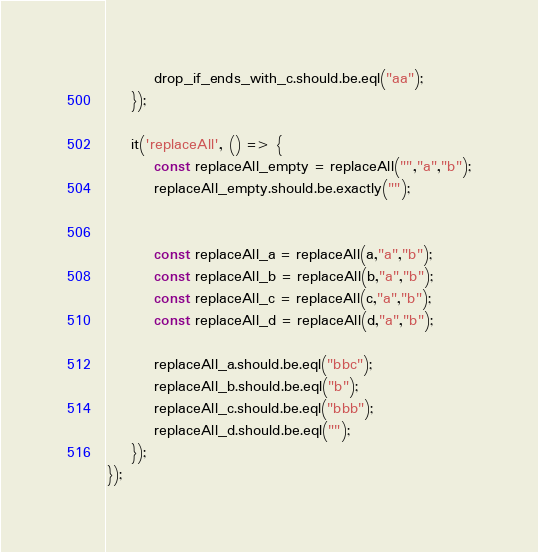Convert code to text. <code><loc_0><loc_0><loc_500><loc_500><_JavaScript_>        drop_if_ends_with_c.should.be.eql("aa");
    });

    it('replaceAll', () => {
        const replaceAll_empty = replaceAll("","a","b");
        replaceAll_empty.should.be.exactly("");


        const replaceAll_a = replaceAll(a,"a","b");
        const replaceAll_b = replaceAll(b,"a","b");
        const replaceAll_c = replaceAll(c,"a","b");
        const replaceAll_d = replaceAll(d,"a","b");
        
        replaceAll_a.should.be.eql("bbc");
        replaceAll_b.should.be.eql("b");
        replaceAll_c.should.be.eql("bbb");
        replaceAll_d.should.be.eql("");
    });
});</code> 